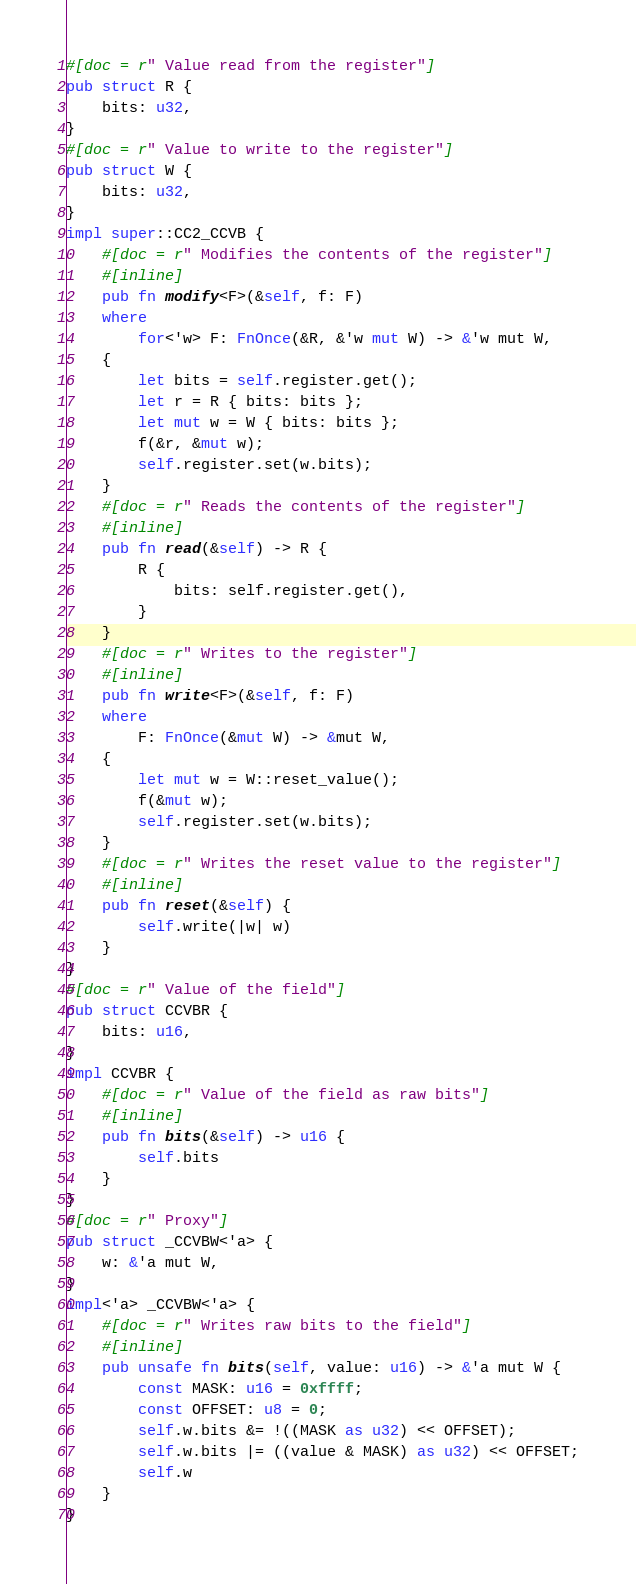<code> <loc_0><loc_0><loc_500><loc_500><_Rust_>#[doc = r" Value read from the register"]
pub struct R {
    bits: u32,
}
#[doc = r" Value to write to the register"]
pub struct W {
    bits: u32,
}
impl super::CC2_CCVB {
    #[doc = r" Modifies the contents of the register"]
    #[inline]
    pub fn modify<F>(&self, f: F)
    where
        for<'w> F: FnOnce(&R, &'w mut W) -> &'w mut W,
    {
        let bits = self.register.get();
        let r = R { bits: bits };
        let mut w = W { bits: bits };
        f(&r, &mut w);
        self.register.set(w.bits);
    }
    #[doc = r" Reads the contents of the register"]
    #[inline]
    pub fn read(&self) -> R {
        R {
            bits: self.register.get(),
        }
    }
    #[doc = r" Writes to the register"]
    #[inline]
    pub fn write<F>(&self, f: F)
    where
        F: FnOnce(&mut W) -> &mut W,
    {
        let mut w = W::reset_value();
        f(&mut w);
        self.register.set(w.bits);
    }
    #[doc = r" Writes the reset value to the register"]
    #[inline]
    pub fn reset(&self) {
        self.write(|w| w)
    }
}
#[doc = r" Value of the field"]
pub struct CCVBR {
    bits: u16,
}
impl CCVBR {
    #[doc = r" Value of the field as raw bits"]
    #[inline]
    pub fn bits(&self) -> u16 {
        self.bits
    }
}
#[doc = r" Proxy"]
pub struct _CCVBW<'a> {
    w: &'a mut W,
}
impl<'a> _CCVBW<'a> {
    #[doc = r" Writes raw bits to the field"]
    #[inline]
    pub unsafe fn bits(self, value: u16) -> &'a mut W {
        const MASK: u16 = 0xffff;
        const OFFSET: u8 = 0;
        self.w.bits &= !((MASK as u32) << OFFSET);
        self.w.bits |= ((value & MASK) as u32) << OFFSET;
        self.w
    }
}</code> 